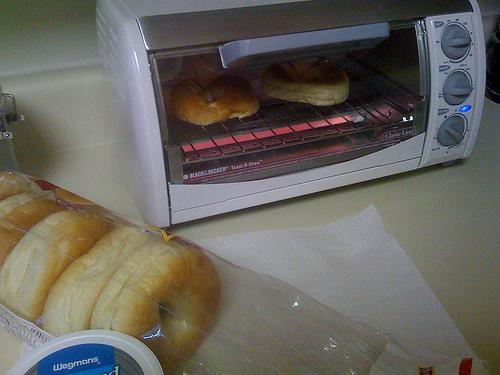Question: where is the cream cheese from?
Choices:
A. Philadelphia.
B. A vegan producer.
C. An organic farm.
D. Wegmans.
Answer with the letter. Answer: D Question: what meal is this?
Choices:
A. Lunch.
B. Breakfast.
C. Dinner.
D. Thanksgiving.
Answer with the letter. Answer: B Question: where are the extra bagels?
Choices:
A. Where is the soap.
B. Where are my keys.
C. Counter.
D. Where did I put my beer.
Answer with the letter. Answer: C 